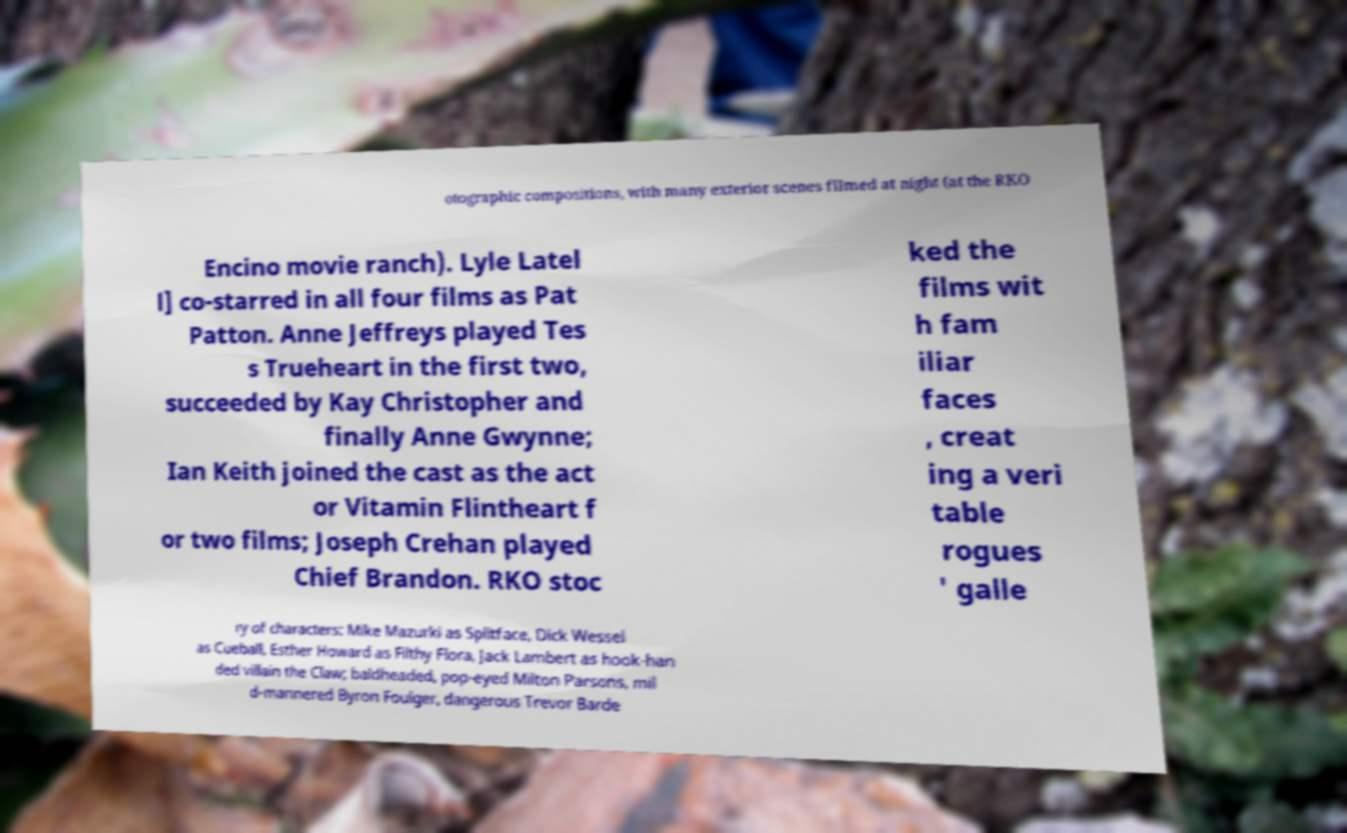There's text embedded in this image that I need extracted. Can you transcribe it verbatim? otographic compositions, with many exterior scenes filmed at night (at the RKO Encino movie ranch). Lyle Latel l] co-starred in all four films as Pat Patton. Anne Jeffreys played Tes s Trueheart in the first two, succeeded by Kay Christopher and finally Anne Gwynne; Ian Keith joined the cast as the act or Vitamin Flintheart f or two films; Joseph Crehan played Chief Brandon. RKO stoc ked the films wit h fam iliar faces , creat ing a veri table rogues ' galle ry of characters: Mike Mazurki as Splitface, Dick Wessel as Cueball, Esther Howard as Filthy Flora, Jack Lambert as hook-han ded villain the Claw; baldheaded, pop-eyed Milton Parsons, mil d-mannered Byron Foulger, dangerous Trevor Barde 